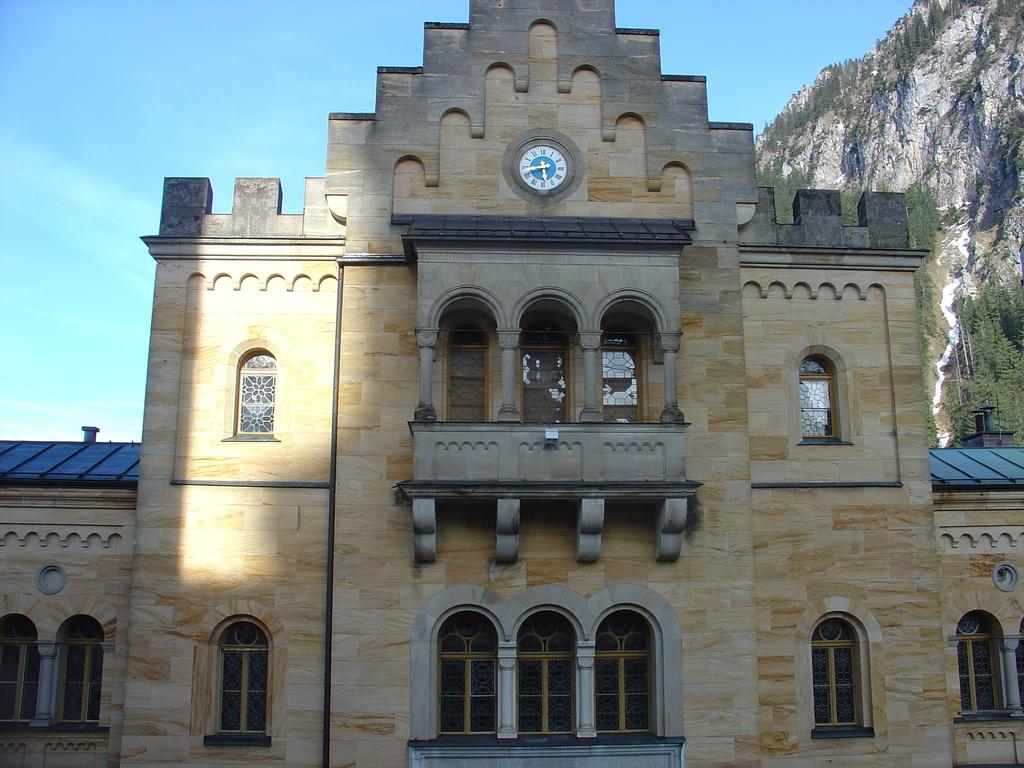What type of structure is visible in the image? There is a building in the image. What architectural feature can be seen in the image? There is a wall in the image. What type of windows are present in the building? There are glass windows in the image. What other structural elements can be seen in the image? There are pillars in the image. What time-keeping device is present in the image? There is a clock in the image. What can be seen in the background of the image? The sky, mountains, and trees are visible in the background of the image. How many feathers are attached to the bulb in the image? There is no bulb or feathers present in the image. What type of credit is being offered to the viewer in the image? There is no credit or financial offer being made in the image. 